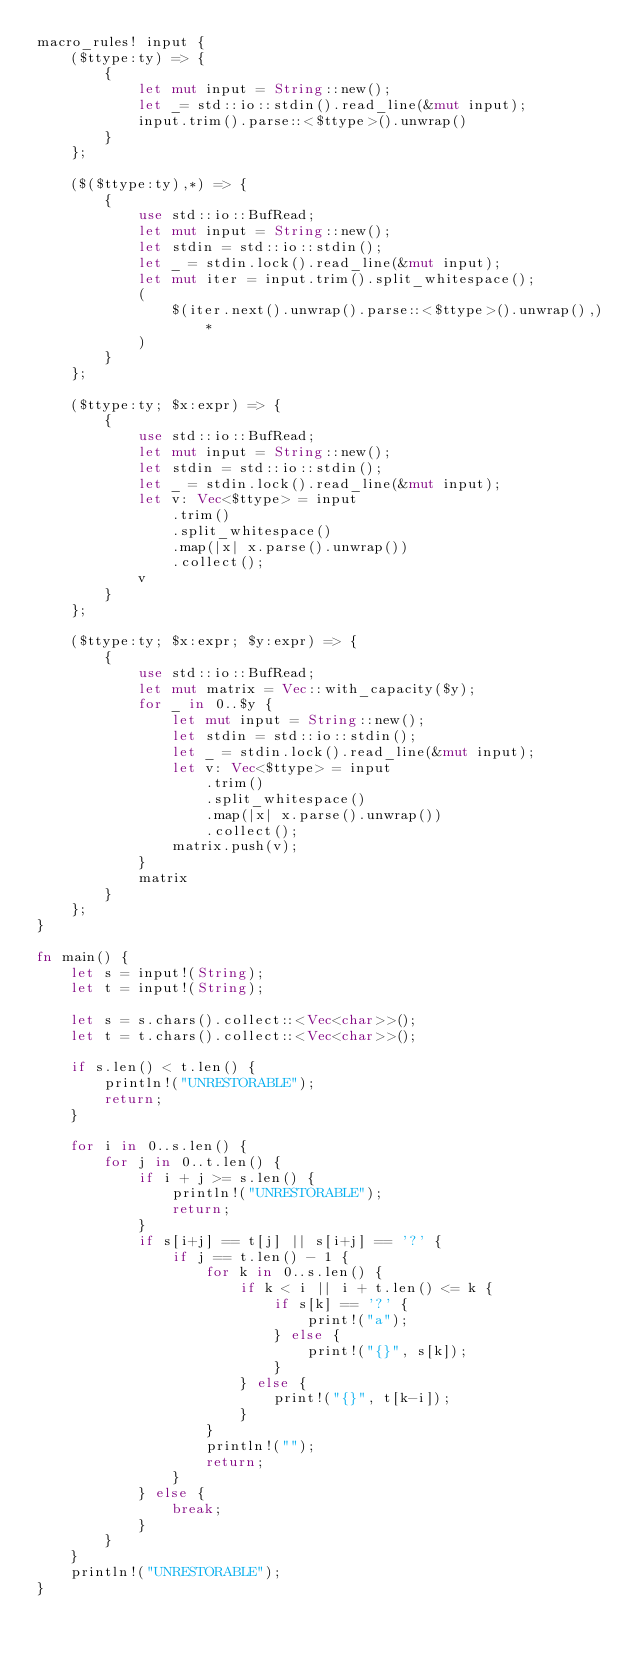<code> <loc_0><loc_0><loc_500><loc_500><_Rust_>macro_rules! input {
    ($ttype:ty) => {
        {
            let mut input = String::new();
            let _= std::io::stdin().read_line(&mut input);
            input.trim().parse::<$ttype>().unwrap()
        }
    };

    ($($ttype:ty),*) => {
        {
            use std::io::BufRead;
            let mut input = String::new();
            let stdin = std::io::stdin();
            let _ = stdin.lock().read_line(&mut input);
            let mut iter = input.trim().split_whitespace();
            (
                $(iter.next().unwrap().parse::<$ttype>().unwrap(),)*
            )
        }
    };

    ($ttype:ty; $x:expr) => {
        {
            use std::io::BufRead;
            let mut input = String::new();
            let stdin = std::io::stdin();
            let _ = stdin.lock().read_line(&mut input);
            let v: Vec<$ttype> = input
                .trim()
                .split_whitespace()
                .map(|x| x.parse().unwrap())
                .collect();
            v
        }
    };

    ($ttype:ty; $x:expr; $y:expr) => {
        {
            use std::io::BufRead;
            let mut matrix = Vec::with_capacity($y);
            for _ in 0..$y {
                let mut input = String::new();
                let stdin = std::io::stdin();
                let _ = stdin.lock().read_line(&mut input);
                let v: Vec<$ttype> = input
                    .trim()
                    .split_whitespace()
                    .map(|x| x.parse().unwrap())
                    .collect();
                matrix.push(v);
            }
            matrix
        }
    };
}

fn main() {
    let s = input!(String);
    let t = input!(String);

    let s = s.chars().collect::<Vec<char>>();
    let t = t.chars().collect::<Vec<char>>();

    if s.len() < t.len() {
        println!("UNRESTORABLE");
        return;
    }

    for i in 0..s.len() {
        for j in 0..t.len() {
            if i + j >= s.len() {
                println!("UNRESTORABLE");
                return;
            }
            if s[i+j] == t[j] || s[i+j] == '?' {
                if j == t.len() - 1 {
                    for k in 0..s.len() {
                        if k < i || i + t.len() <= k {
                            if s[k] == '?' {
                                print!("a");
                            } else {
                                print!("{}", s[k]);
                            }
                        } else {
                            print!("{}", t[k-i]);
                        }
                    }
                    println!("");
                    return;
                }
            } else {
                break;
            }
        }
    }
    println!("UNRESTORABLE");
}</code> 